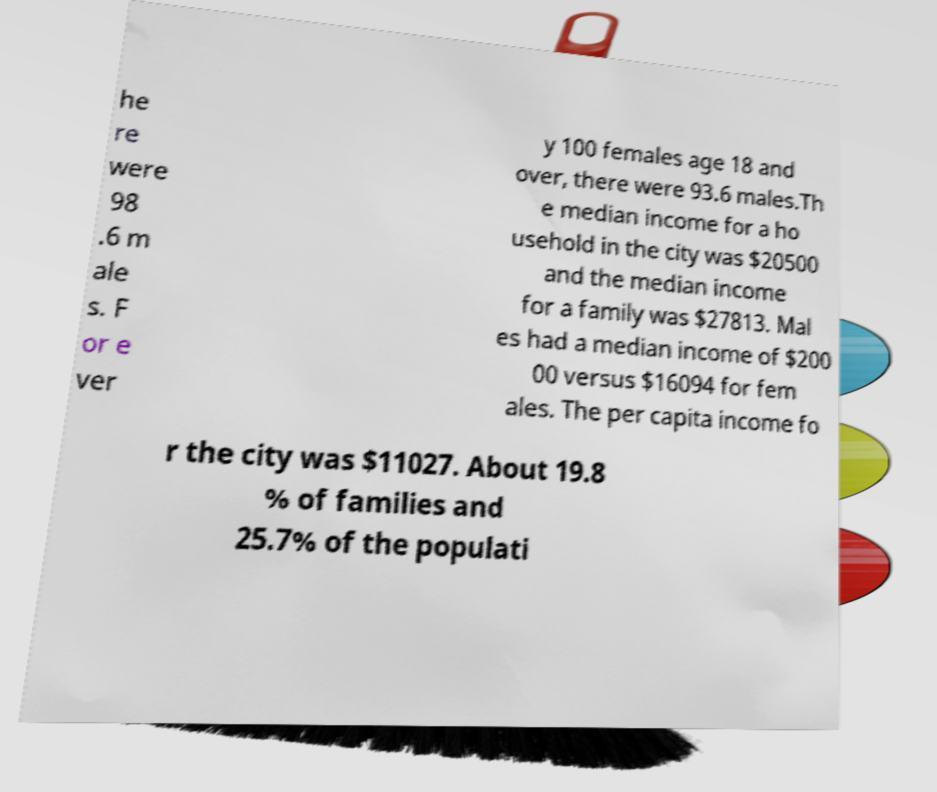There's text embedded in this image that I need extracted. Can you transcribe it verbatim? he re were 98 .6 m ale s. F or e ver y 100 females age 18 and over, there were 93.6 males.Th e median income for a ho usehold in the city was $20500 and the median income for a family was $27813. Mal es had a median income of $200 00 versus $16094 for fem ales. The per capita income fo r the city was $11027. About 19.8 % of families and 25.7% of the populati 